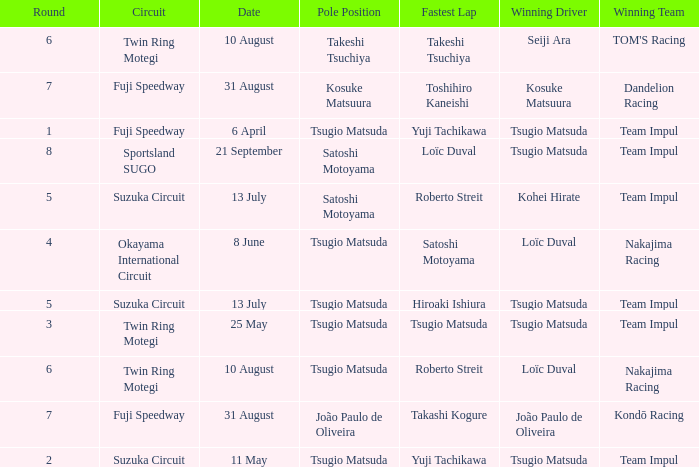What is the fastest lap for Seiji Ara? Takeshi Tsuchiya. 